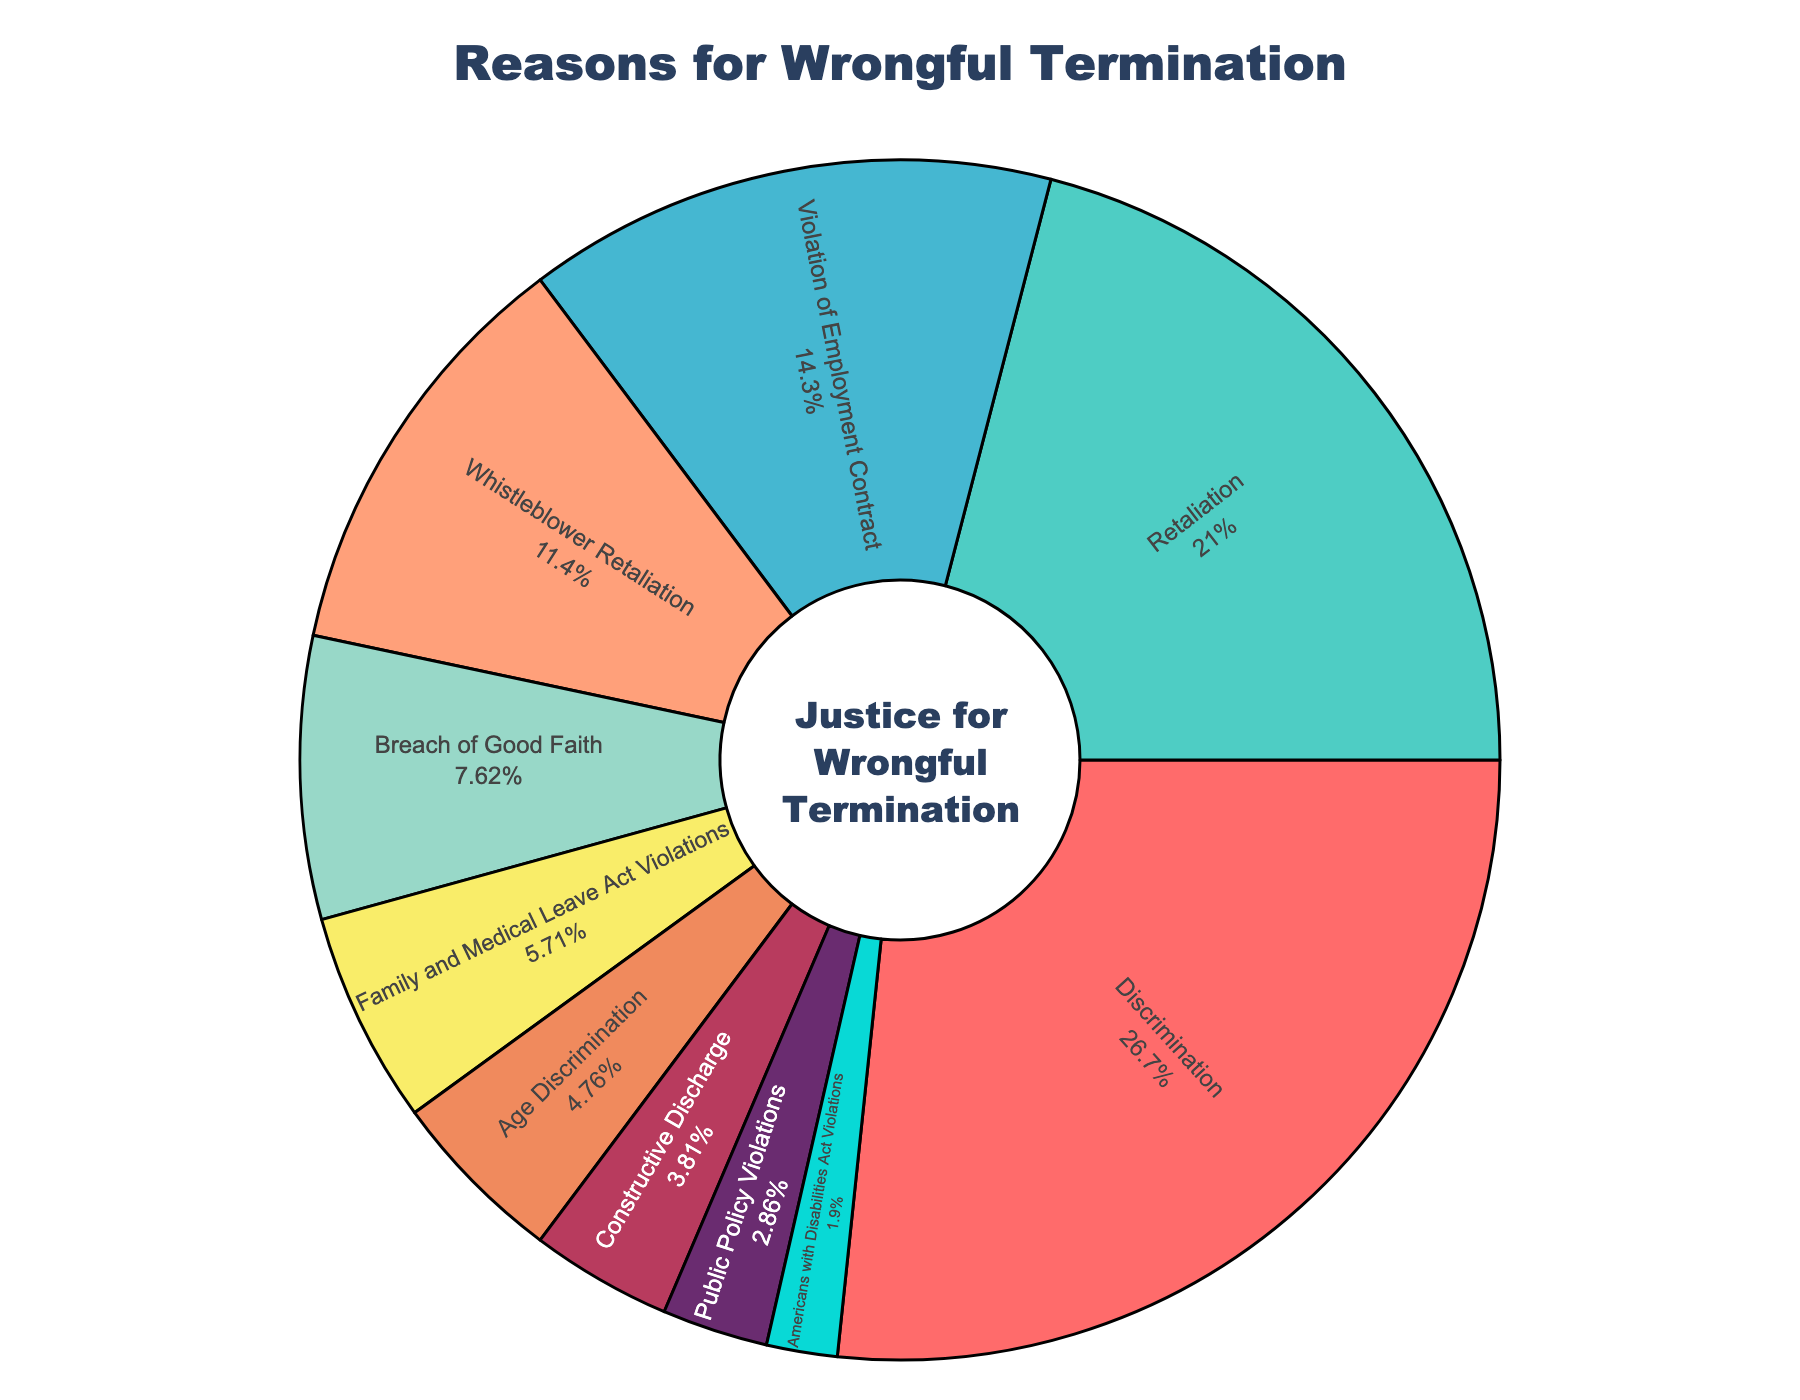What's the largest percentage category in the pie chart? To determine the largest percentage category, look for the slice with the highest percentage in the figure. In this case, "Discrimination" occupies 28% of the pie chart.
Answer: Discrimination How much higher is the percentage for Retaliation than for Americans with Disabilities Act Violations? Compare the percentages for Retaliation (22%) and Americans with Disabilities Act Violations (2%). Subtract 2 from 22 to find the difference.
Answer: 20% Which category has a lower percentage: Age Discrimination or Constructive Discharge? Identify the percentages of Age Discrimination (5%) and Constructive Discharge (4%) and compare them.
Answer: Constructive Discharge Is the sum of percentage for Violation of Employment Contract and Whistleblower Retaliation greater than 40%? Add the percentages of Violation of Employment Contract (15%) and Whistleblower Retaliation (12%). The sum is 15 + 12 = 27. Hence, it's not greater than 40%.
Answer: No What's the median value of the category percentages? List the percentages in numerical order: 2, 3, 4, 5, 6, 8, 12, 15, 22, 28. The median is the average of the 5th and 6th values: (6 + 8) / 2 = 7.
Answer: 7 Which category is represented by the red color in the chart? Locate the slice with the red color visually in the pie chart. According to the data provided, it is the "Discrimination" category.
Answer: Discrimination What is the combined percentage for categories that deal with retaliation in some form? Sum the percentages of Retaliation (22%) and Whistleblower Retaliation (12%) for their total combined share. The sum is 34%.
Answer: 34% Are the cumulative percentages of Family and Medical Leave Act Violations and Public Policy Violations greater than Violation of Employment Contract? Add the percentages of Family and Medical Leave Act Violations (6%) and Public Policy Violations (3%). Their total is 6 + 3 = 9, which is less than the Violation of Employment Contract's 15%.
Answer: No Does the pie chart show any category with a percentage less than 5%? Check the chart for slices with percentages less than 5%. Both Constructive Discharge (4%), Public Policy Violations (3%), and Americans with Disabilities Act Violations (2%) fit this criteria.
Answer: Yes 